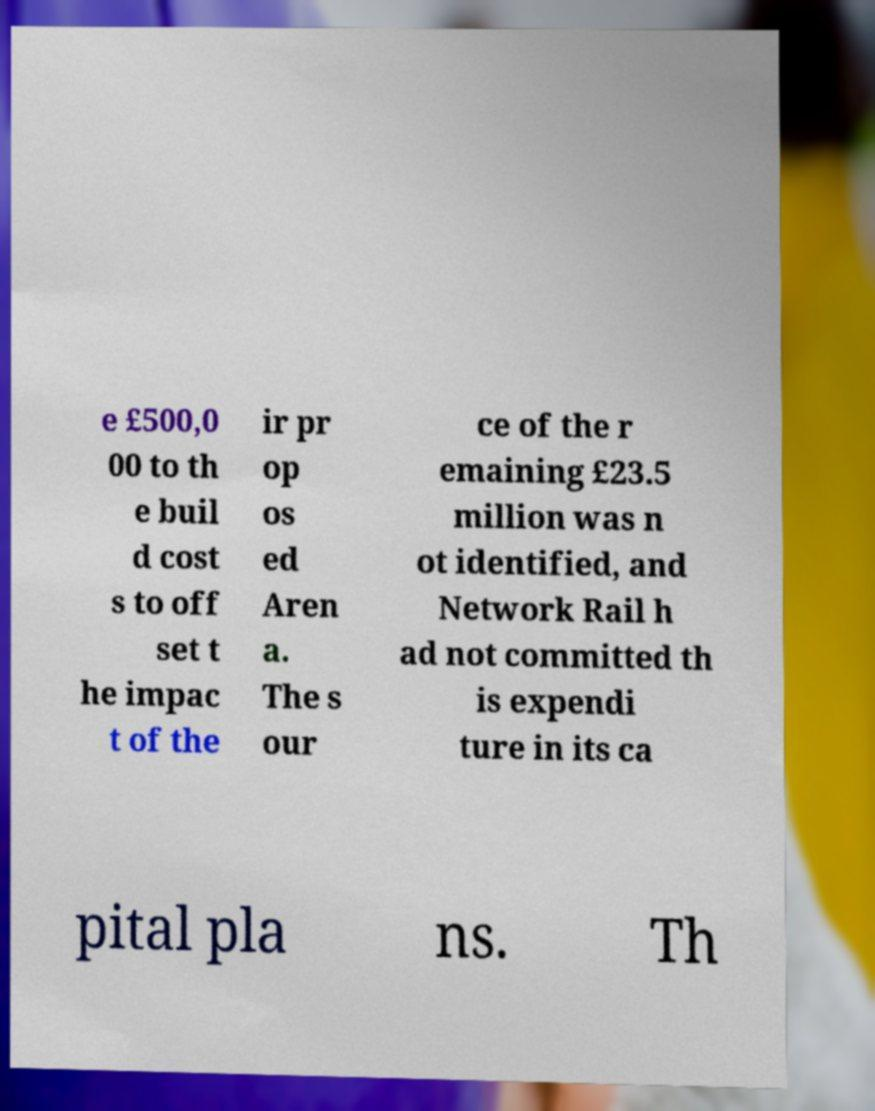What messages or text are displayed in this image? I need them in a readable, typed format. e £500,0 00 to th e buil d cost s to off set t he impac t of the ir pr op os ed Aren a. The s our ce of the r emaining £23.5 million was n ot identified, and Network Rail h ad not committed th is expendi ture in its ca pital pla ns. Th 